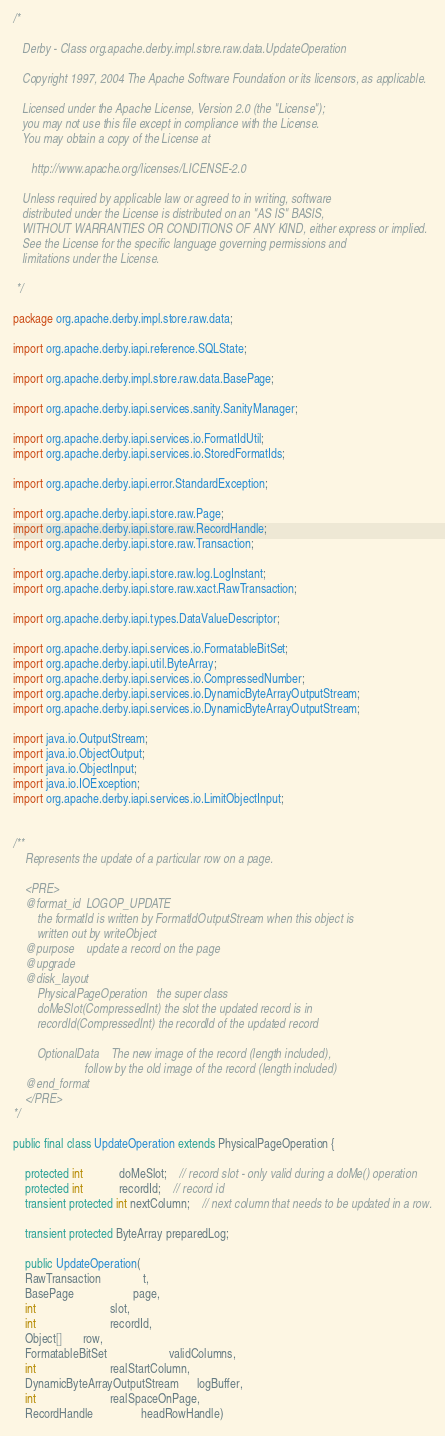<code> <loc_0><loc_0><loc_500><loc_500><_Java_>/*

   Derby - Class org.apache.derby.impl.store.raw.data.UpdateOperation

   Copyright 1997, 2004 The Apache Software Foundation or its licensors, as applicable.

   Licensed under the Apache License, Version 2.0 (the "License");
   you may not use this file except in compliance with the License.
   You may obtain a copy of the License at

      http://www.apache.org/licenses/LICENSE-2.0

   Unless required by applicable law or agreed to in writing, software
   distributed under the License is distributed on an "AS IS" BASIS,
   WITHOUT WARRANTIES OR CONDITIONS OF ANY KIND, either express or implied.
   See the License for the specific language governing permissions and
   limitations under the License.

 */

package org.apache.derby.impl.store.raw.data;

import org.apache.derby.iapi.reference.SQLState;

import org.apache.derby.impl.store.raw.data.BasePage;

import org.apache.derby.iapi.services.sanity.SanityManager;

import org.apache.derby.iapi.services.io.FormatIdUtil;
import org.apache.derby.iapi.services.io.StoredFormatIds;

import org.apache.derby.iapi.error.StandardException;

import org.apache.derby.iapi.store.raw.Page;
import org.apache.derby.iapi.store.raw.RecordHandle;
import org.apache.derby.iapi.store.raw.Transaction;

import org.apache.derby.iapi.store.raw.log.LogInstant;
import org.apache.derby.iapi.store.raw.xact.RawTransaction; 

import org.apache.derby.iapi.types.DataValueDescriptor;

import org.apache.derby.iapi.services.io.FormatableBitSet;
import org.apache.derby.iapi.util.ByteArray;
import org.apache.derby.iapi.services.io.CompressedNumber;
import org.apache.derby.iapi.services.io.DynamicByteArrayOutputStream;
import org.apache.derby.iapi.services.io.DynamicByteArrayOutputStream;

import java.io.OutputStream;
import java.io.ObjectOutput;
import java.io.ObjectInput;
import java.io.IOException;
import org.apache.derby.iapi.services.io.LimitObjectInput;


/**
	Represents the update of a particular row on a page.

	<PRE>
	@format_id	LOGOP_UPDATE
		the formatId is written by FormatIdOutputStream when this object is
		written out by writeObject
	@purpose	update a record on the page
	@upgrade
	@disk_layout
		PhysicalPageOperation	the super class
		doMeSlot(CompressedInt)	the slot the updated record is in
		recordId(CompressedInt) the recordId of the updated record

		OptionalData	The new image of the record (length included), 
						follow by the old image of the record (length included)
	@end_format
	</PRE>
*/

public final class UpdateOperation extends PhysicalPageOperation {

	protected int			doMeSlot;	// record slot - only valid during a doMe() operation
	protected int			recordId;	// record id
	transient protected int nextColumn;	// next column that needs to be updated in a row.

	transient protected ByteArray preparedLog;
	
	public UpdateOperation(
    RawTransaction              t, 
    BasePage                    page, 
    int                         slot, 
    int                         recordId,
    Object[]       row, 
    FormatableBitSet                     validColumns,
    int                         realStartColumn, 
    DynamicByteArrayOutputStream      logBuffer, 
    int                         realSpaceOnPage, 
    RecordHandle                headRowHandle)</code> 